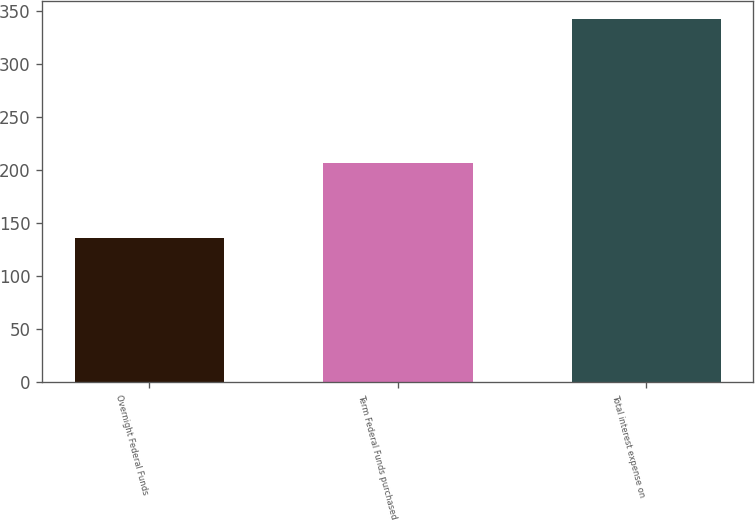Convert chart to OTSL. <chart><loc_0><loc_0><loc_500><loc_500><bar_chart><fcel>Overnight Federal Funds<fcel>Term Federal Funds purchased<fcel>Total interest expense on<nl><fcel>136<fcel>207<fcel>343<nl></chart> 